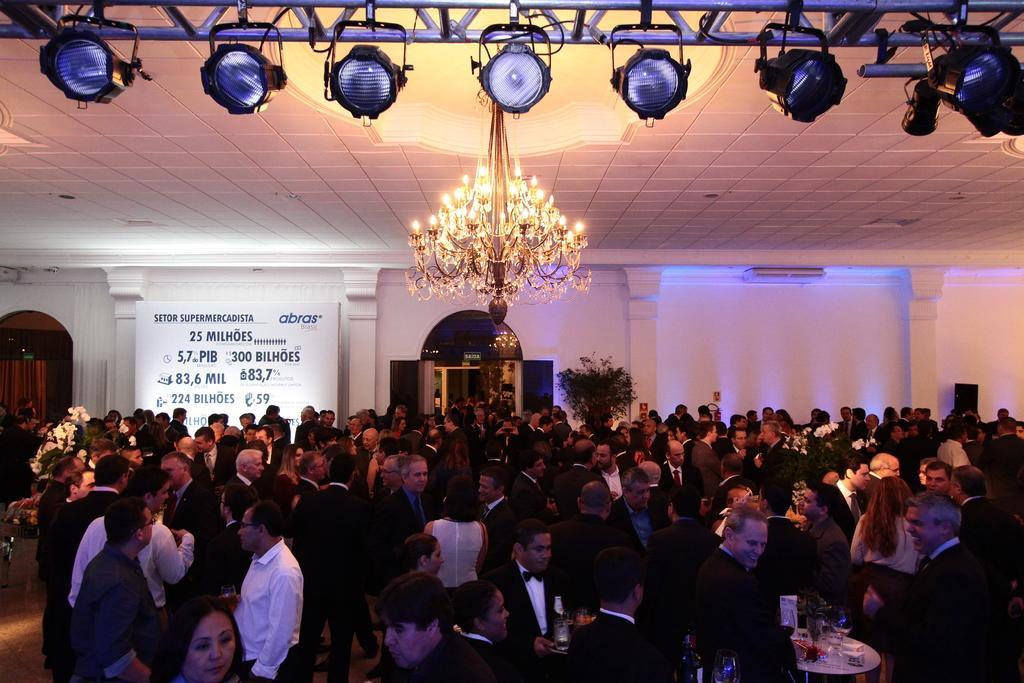How would you summarize this image in a sentence or two? In this image I can see some people. I can see some objects on the table. In the background, I can see a board with some text written on it. I can also see a door and a plant. At the top I can see the lights. 